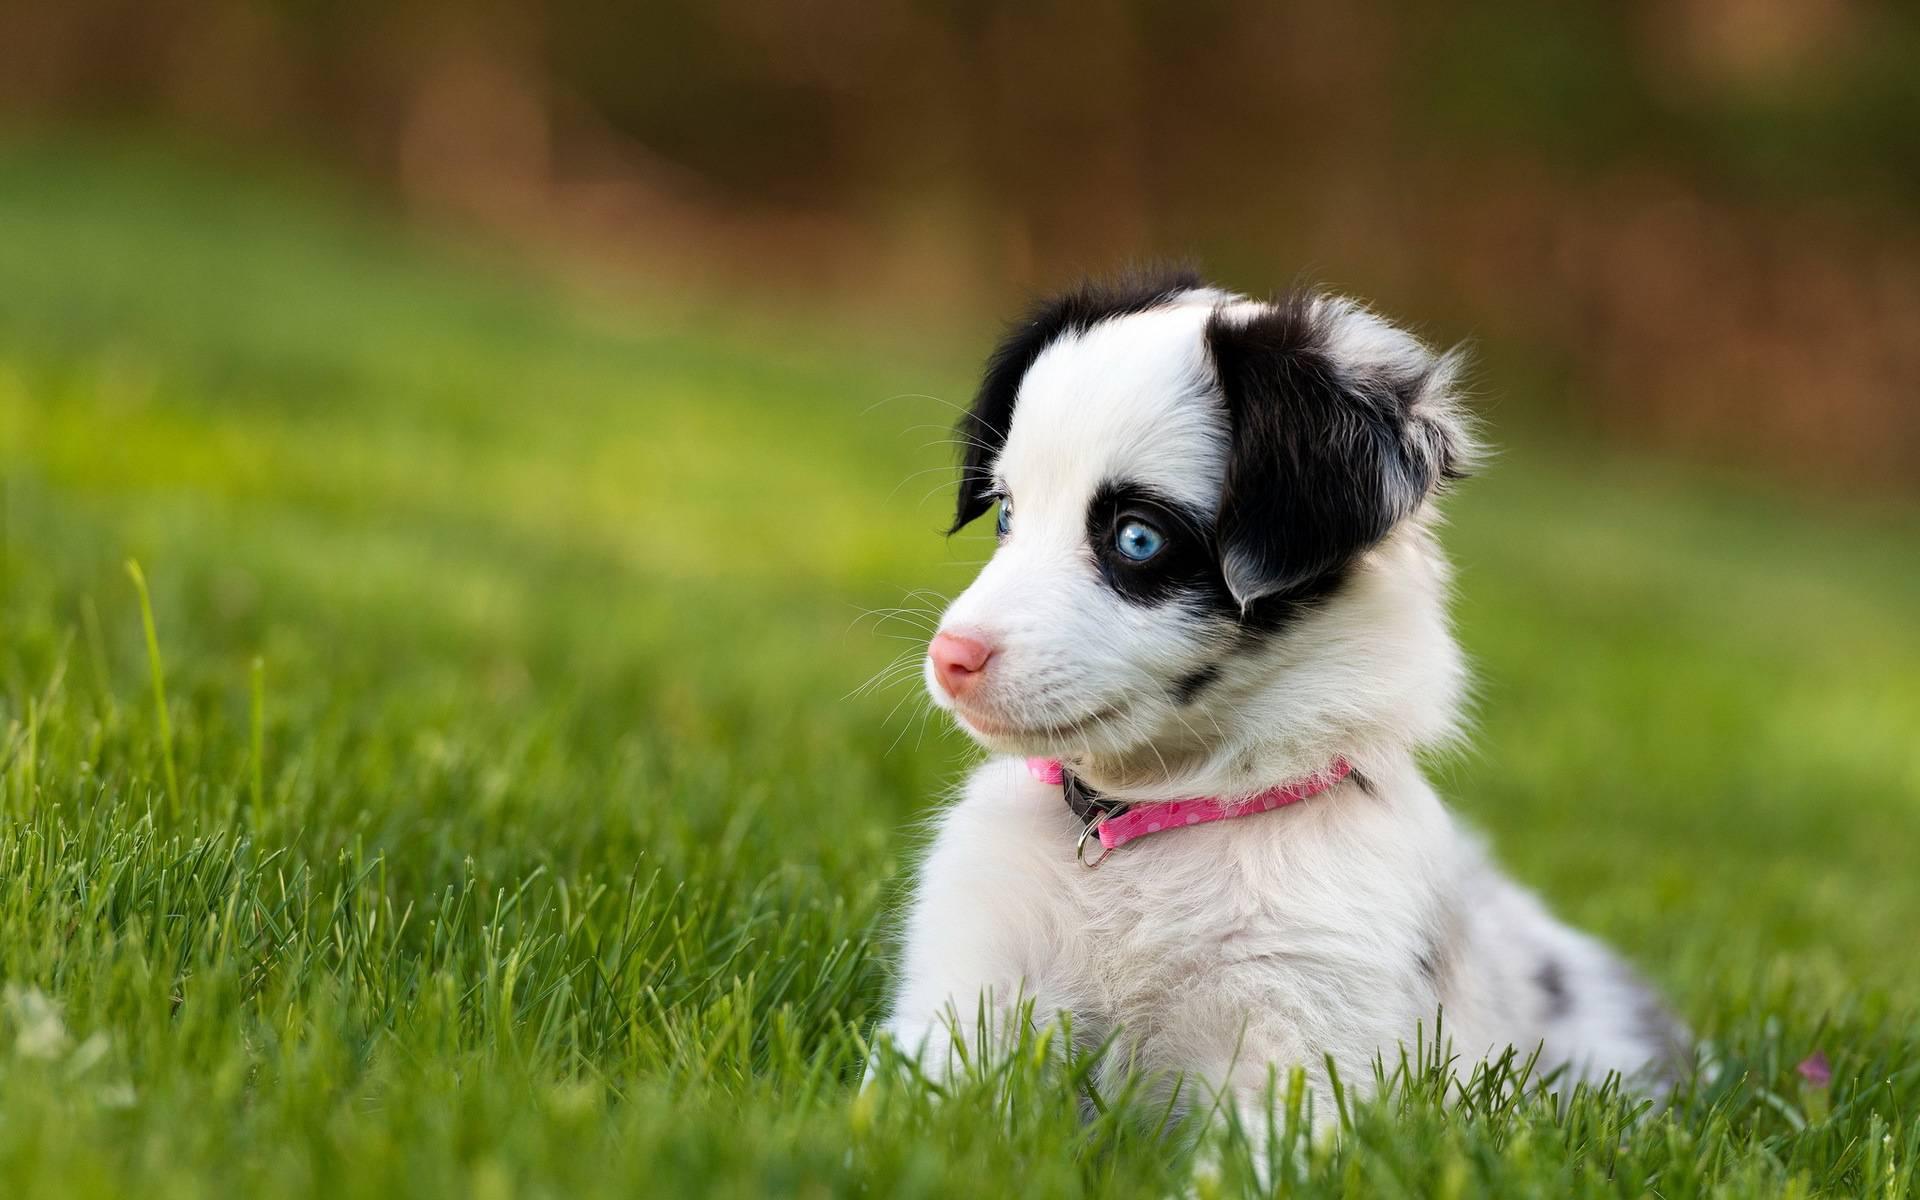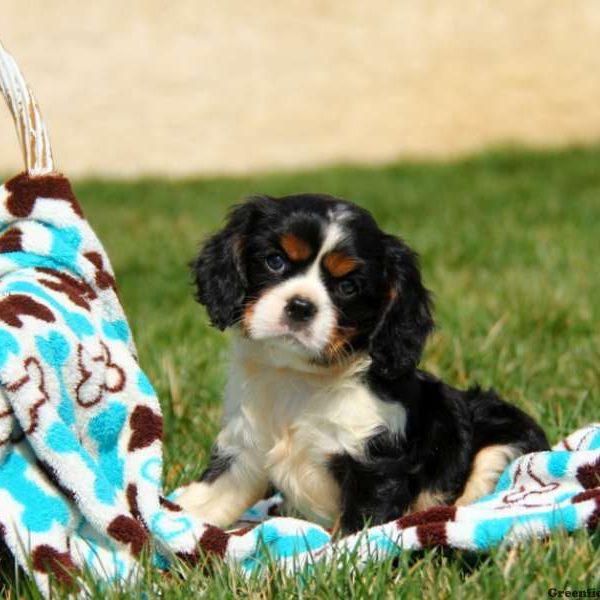The first image is the image on the left, the second image is the image on the right. Assess this claim about the two images: "The right image shows a row of four young dogs.". Correct or not? Answer yes or no. No. 